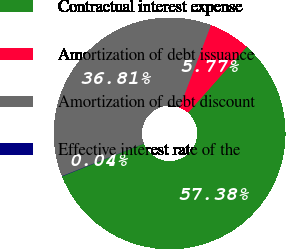Convert chart to OTSL. <chart><loc_0><loc_0><loc_500><loc_500><pie_chart><fcel>Contractual interest expense<fcel>Amortization of debt issuance<fcel>Amortization of debt discount<fcel>Effective interest rate of the<nl><fcel>57.38%<fcel>5.77%<fcel>36.81%<fcel>0.04%<nl></chart> 